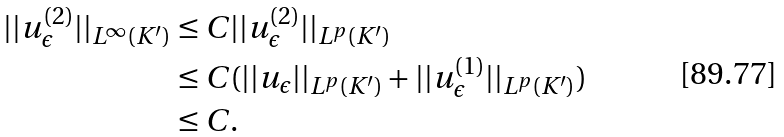Convert formula to latex. <formula><loc_0><loc_0><loc_500><loc_500>| | u _ { \epsilon } ^ { ( 2 ) } | | _ { L ^ { \infty } ( K ^ { \prime } ) } & \leq C | | u _ { \epsilon } ^ { ( 2 ) } | | _ { L ^ { p } ( K ^ { \prime } ) } \\ & \leq C ( | | u _ { \epsilon } | | _ { L ^ { p } ( K ^ { \prime } ) } + | | u _ { \epsilon } ^ { ( 1 ) } | | _ { L ^ { p } ( K ^ { \prime } ) } ) \\ & \leq C .</formula> 